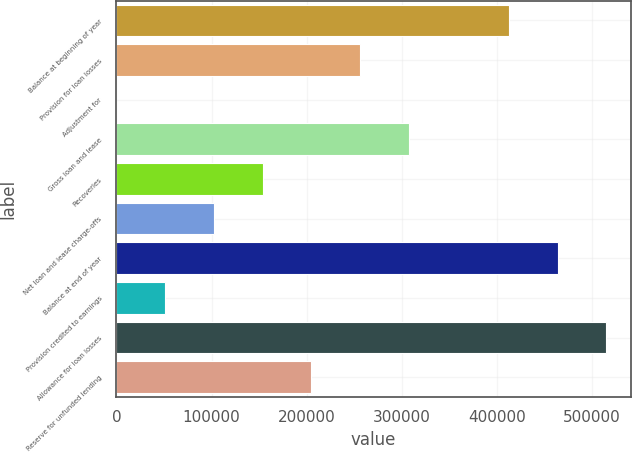<chart> <loc_0><loc_0><loc_500><loc_500><bar_chart><fcel>Balance at beginning of year<fcel>Provision for loan losses<fcel>Adjustment for<fcel>Gross loan and lease<fcel>Recoveries<fcel>Net loan and lease charge-offs<fcel>Balance at end of year<fcel>Provision credited to earnings<fcel>Allowance for loan losses<fcel>Reserve for unfunded lending<nl><fcel>412514<fcel>256015<fcel>57<fcel>307207<fcel>153632<fcel>102440<fcel>463706<fcel>51248.6<fcel>514897<fcel>204823<nl></chart> 